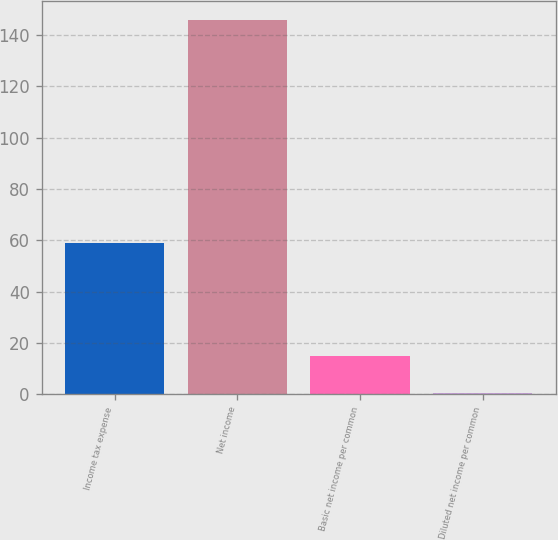<chart> <loc_0><loc_0><loc_500><loc_500><bar_chart><fcel>Income tax expense<fcel>Net income<fcel>Basic net income per common<fcel>Diluted net income per common<nl><fcel>59.1<fcel>146<fcel>14.98<fcel>0.42<nl></chart> 